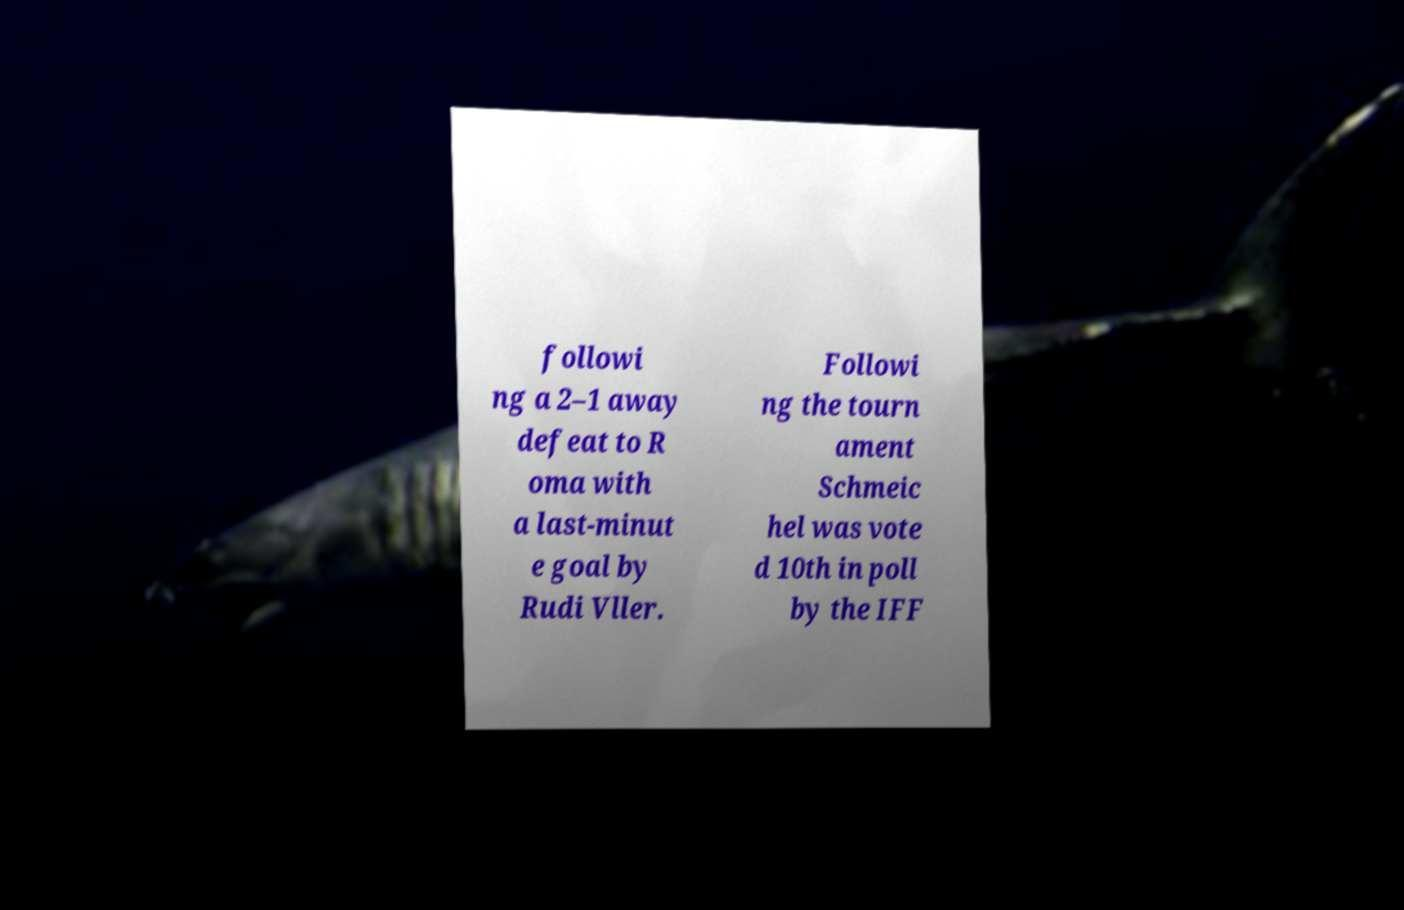Please read and relay the text visible in this image. What does it say? followi ng a 2–1 away defeat to R oma with a last-minut e goal by Rudi Vller. Followi ng the tourn ament Schmeic hel was vote d 10th in poll by the IFF 